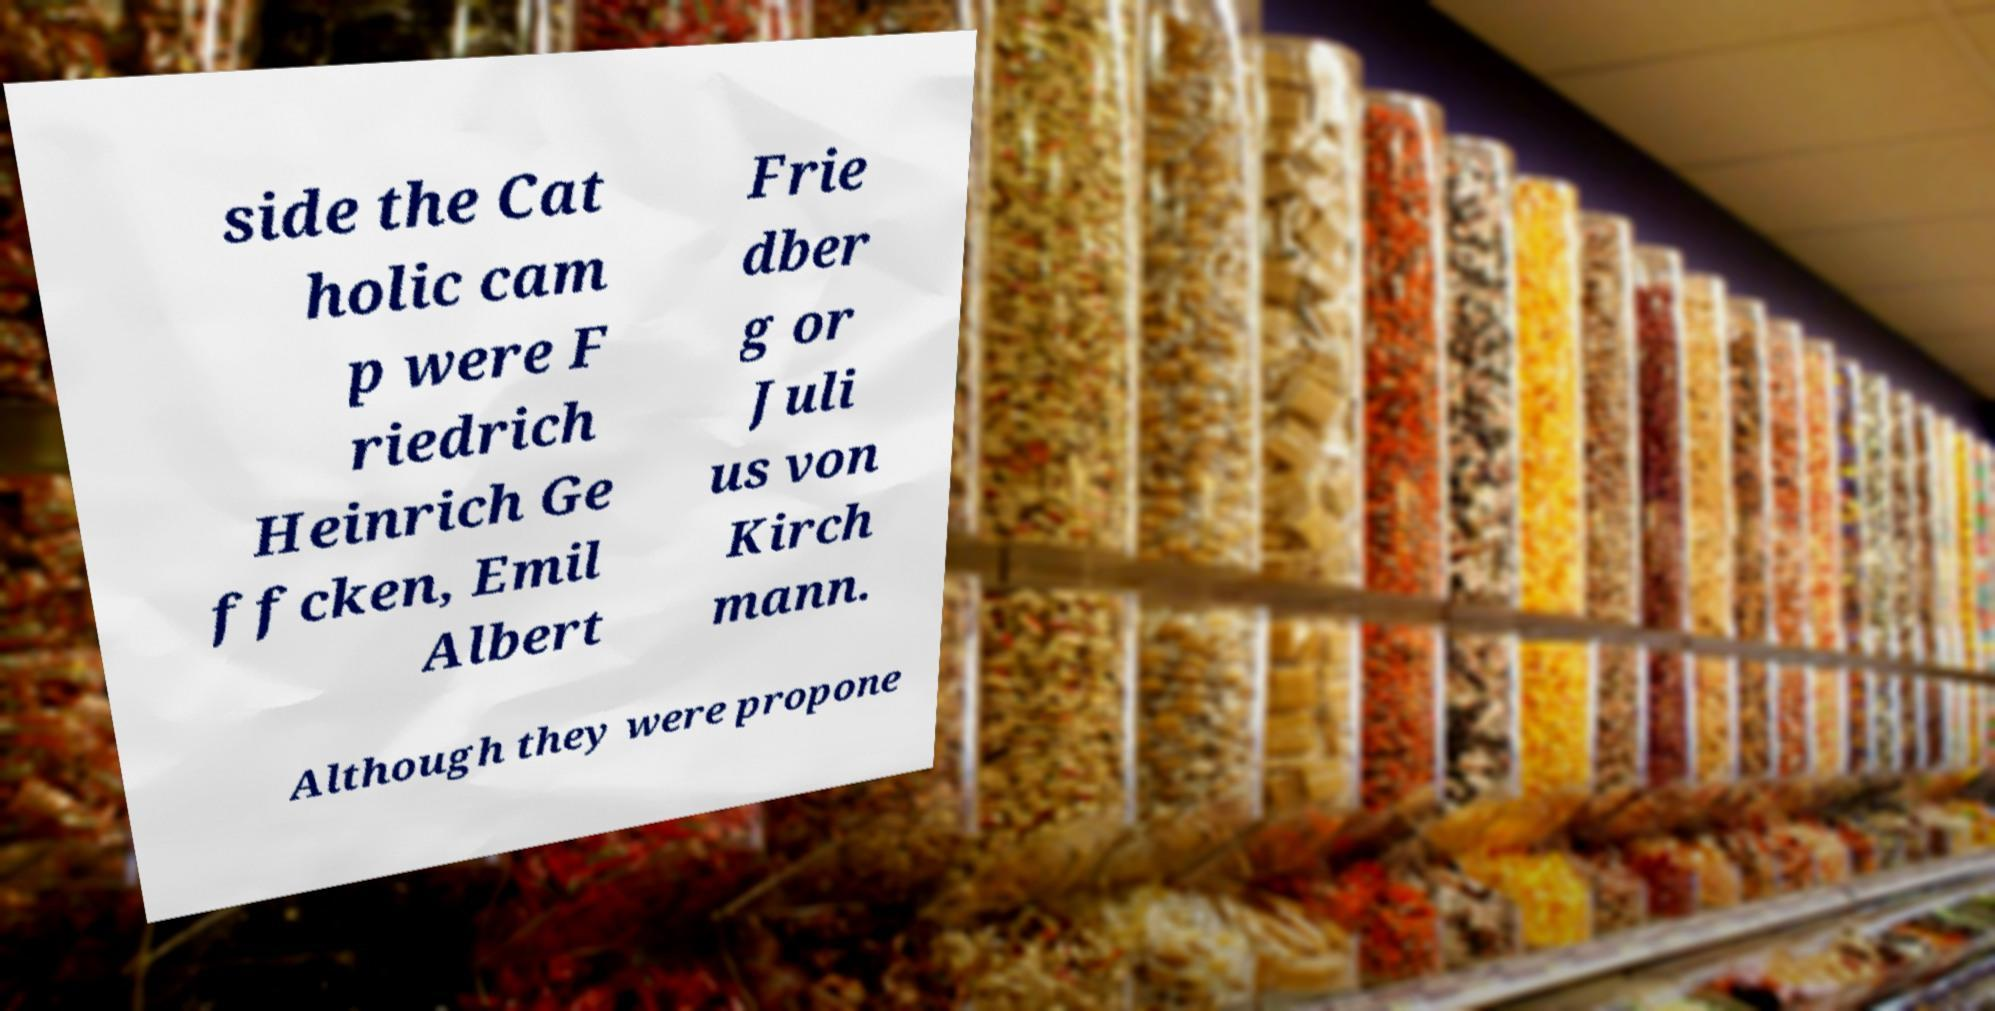For documentation purposes, I need the text within this image transcribed. Could you provide that? side the Cat holic cam p were F riedrich Heinrich Ge ffcken, Emil Albert Frie dber g or Juli us von Kirch mann. Although they were propone 